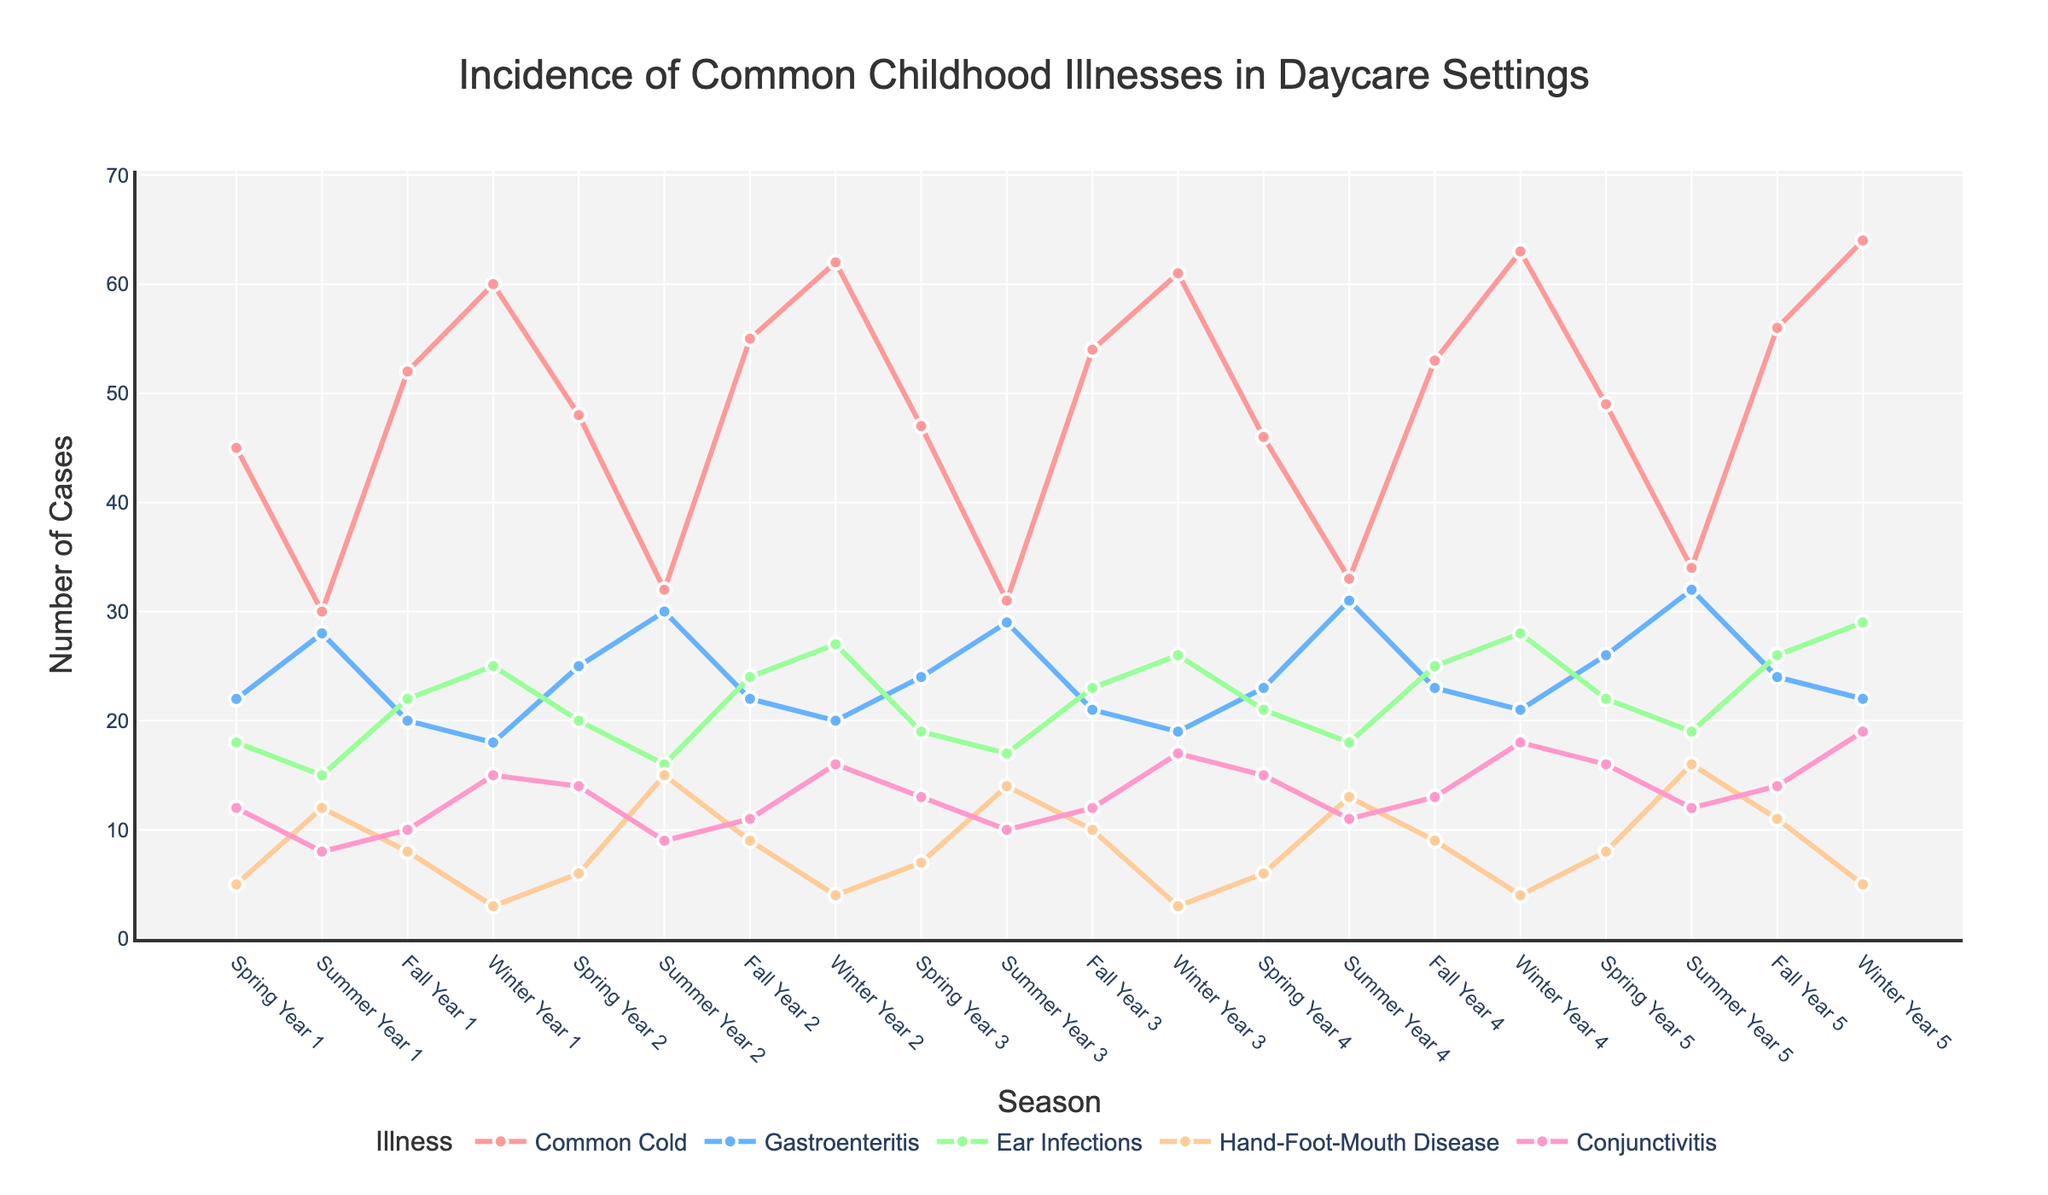What is the average number of Common Cold cases in Winter over the 5-year period? To find the average, sum the number of Common Cold cases in winter for each year: 60 + 62 + 61 + 63 + 64 = 310, then divide by the number of winters (5). The average is 310 / 5 = 62.
Answer: 62 In which season and year is the highest incidence of Gastroenteritis observed? Look for the highest point on the Gastroenteritis line and note the corresponding season and year. The highest value is 32, observed in Summer Year 5.
Answer: Summer Year 5 By how much did the number of Hand-Foot-Mouth Disease cases change from Summer Year 1 to Summer Year 5? Subtract the number of cases in Summer Year 1 from the number of cases in Summer Year 5: 16 - 12 = 4.
Answer: 4 Which illness consistently has the highest number of cases across all seasons? Look at each of the illnesses across all seasons to determine which line, on average, tends to be the highest. It is the Common Cold.
Answer: Common Cold Compare the number of Conjunctivitis cases in Fall Year 1 and Fall Year 5. Which one is higher and by how much? Compare the numbers: Fall Year 1 has 10 cases and Fall Year 5 has 14 cases. 14 - 10 = 4, so Fall Year 5 has 4 more cases.
Answer: Fall Year 5 by 4 What is the trend of Ear Infections during the winter seasons over the 5 years? Look at the points for Ear Infections during each winter and see if they are increasing or decreasing. Values are 25, 27, 26, 28, and 29, indicating an upward trend.
Answer: Upward trend How many illnesses saw their peak incidence in Winter Year 5? Count the number of illnesses for which the highest points fall at Winter Year 5. Common Cold and Conjunctivitis both peak in Winter Year 5.
Answer: 2 Calculate the combined total number of cases of Common Cold and Ear Infections in Spring Year 5. Add the number of Common Cold cases (49) to the number of Ear Infections (22) during Spring Year 5: 49 + 22 = 71.
Answer: 71 Which illness has the least variation in incidence throughout the seasons? Look at the range of values for each illness across all seasons and identify the illness with the smallest range. Hand-Foot-Mouth Disease varies between 3 and 16 cases, which is the least variation.
Answer: Hand-Foot-Mouth Disease 